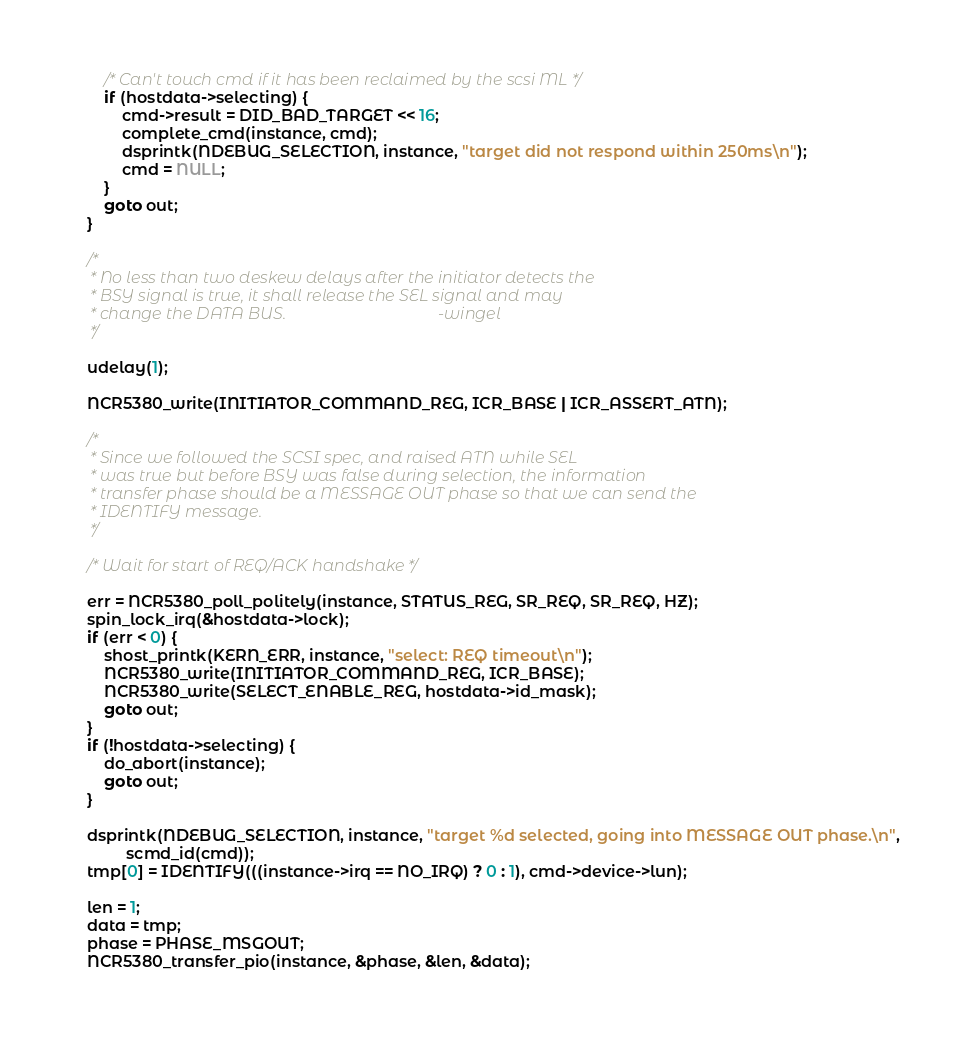Convert code to text. <code><loc_0><loc_0><loc_500><loc_500><_C_>		/* Can't touch cmd if it has been reclaimed by the scsi ML */
		if (hostdata->selecting) {
			cmd->result = DID_BAD_TARGET << 16;
			complete_cmd(instance, cmd);
			dsprintk(NDEBUG_SELECTION, instance, "target did not respond within 250ms\n");
			cmd = NULL;
		}
		goto out;
	}

	/*
	 * No less than two deskew delays after the initiator detects the
	 * BSY signal is true, it shall release the SEL signal and may
	 * change the DATA BUS.                                     -wingel
	 */

	udelay(1);

	NCR5380_write(INITIATOR_COMMAND_REG, ICR_BASE | ICR_ASSERT_ATN);

	/*
	 * Since we followed the SCSI spec, and raised ATN while SEL
	 * was true but before BSY was false during selection, the information
	 * transfer phase should be a MESSAGE OUT phase so that we can send the
	 * IDENTIFY message.
	 */

	/* Wait for start of REQ/ACK handshake */

	err = NCR5380_poll_politely(instance, STATUS_REG, SR_REQ, SR_REQ, HZ);
	spin_lock_irq(&hostdata->lock);
	if (err < 0) {
		shost_printk(KERN_ERR, instance, "select: REQ timeout\n");
		NCR5380_write(INITIATOR_COMMAND_REG, ICR_BASE);
		NCR5380_write(SELECT_ENABLE_REG, hostdata->id_mask);
		goto out;
	}
	if (!hostdata->selecting) {
		do_abort(instance);
		goto out;
	}

	dsprintk(NDEBUG_SELECTION, instance, "target %d selected, going into MESSAGE OUT phase.\n",
	         scmd_id(cmd));
	tmp[0] = IDENTIFY(((instance->irq == NO_IRQ) ? 0 : 1), cmd->device->lun);

	len = 1;
	data = tmp;
	phase = PHASE_MSGOUT;
	NCR5380_transfer_pio(instance, &phase, &len, &data);</code> 